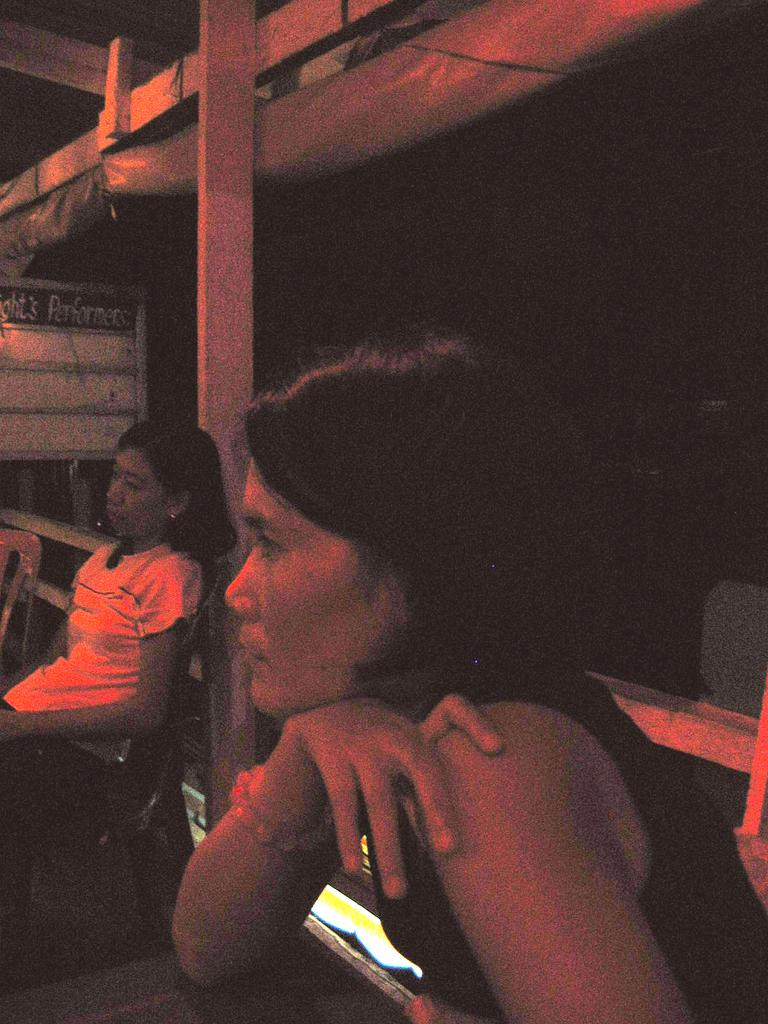What are the people in the image doing? The people in the image are sitting on chairs. What can be seen on the left side of the image? There is a board on the left side of the image. How would you describe the overall lighting in the image? The background of the image is dark. What type of bait is being used on the stage in the image? There is no stage or bait present in the image. 